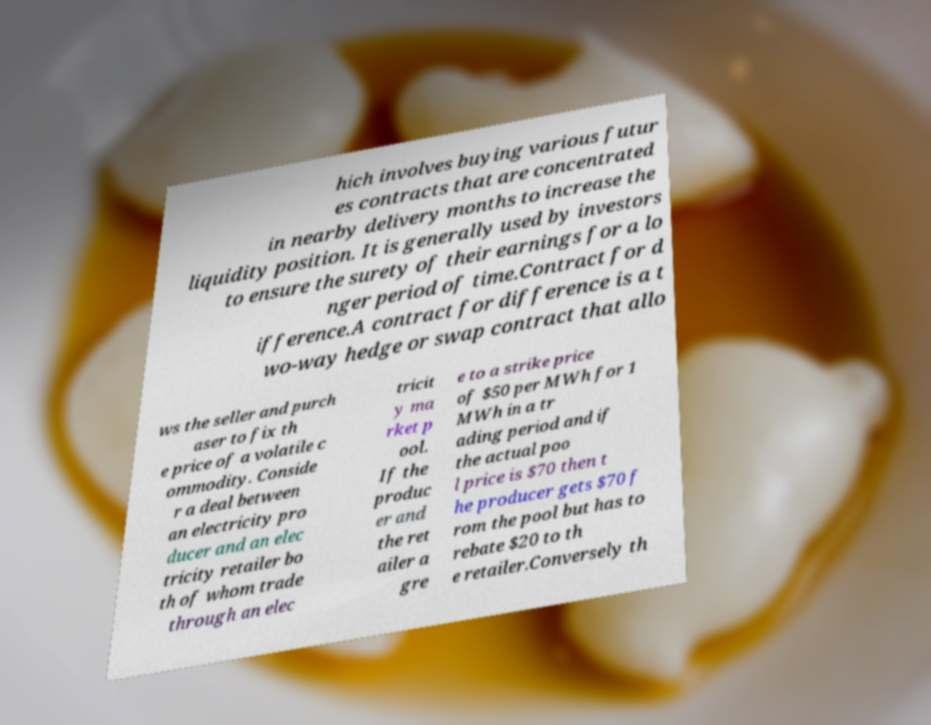Could you assist in decoding the text presented in this image and type it out clearly? hich involves buying various futur es contracts that are concentrated in nearby delivery months to increase the liquidity position. It is generally used by investors to ensure the surety of their earnings for a lo nger period of time.Contract for d ifference.A contract for difference is a t wo-way hedge or swap contract that allo ws the seller and purch aser to fix th e price of a volatile c ommodity. Conside r a deal between an electricity pro ducer and an elec tricity retailer bo th of whom trade through an elec tricit y ma rket p ool. If the produc er and the ret ailer a gre e to a strike price of $50 per MWh for 1 MWh in a tr ading period and if the actual poo l price is $70 then t he producer gets $70 f rom the pool but has to rebate $20 to th e retailer.Conversely th 